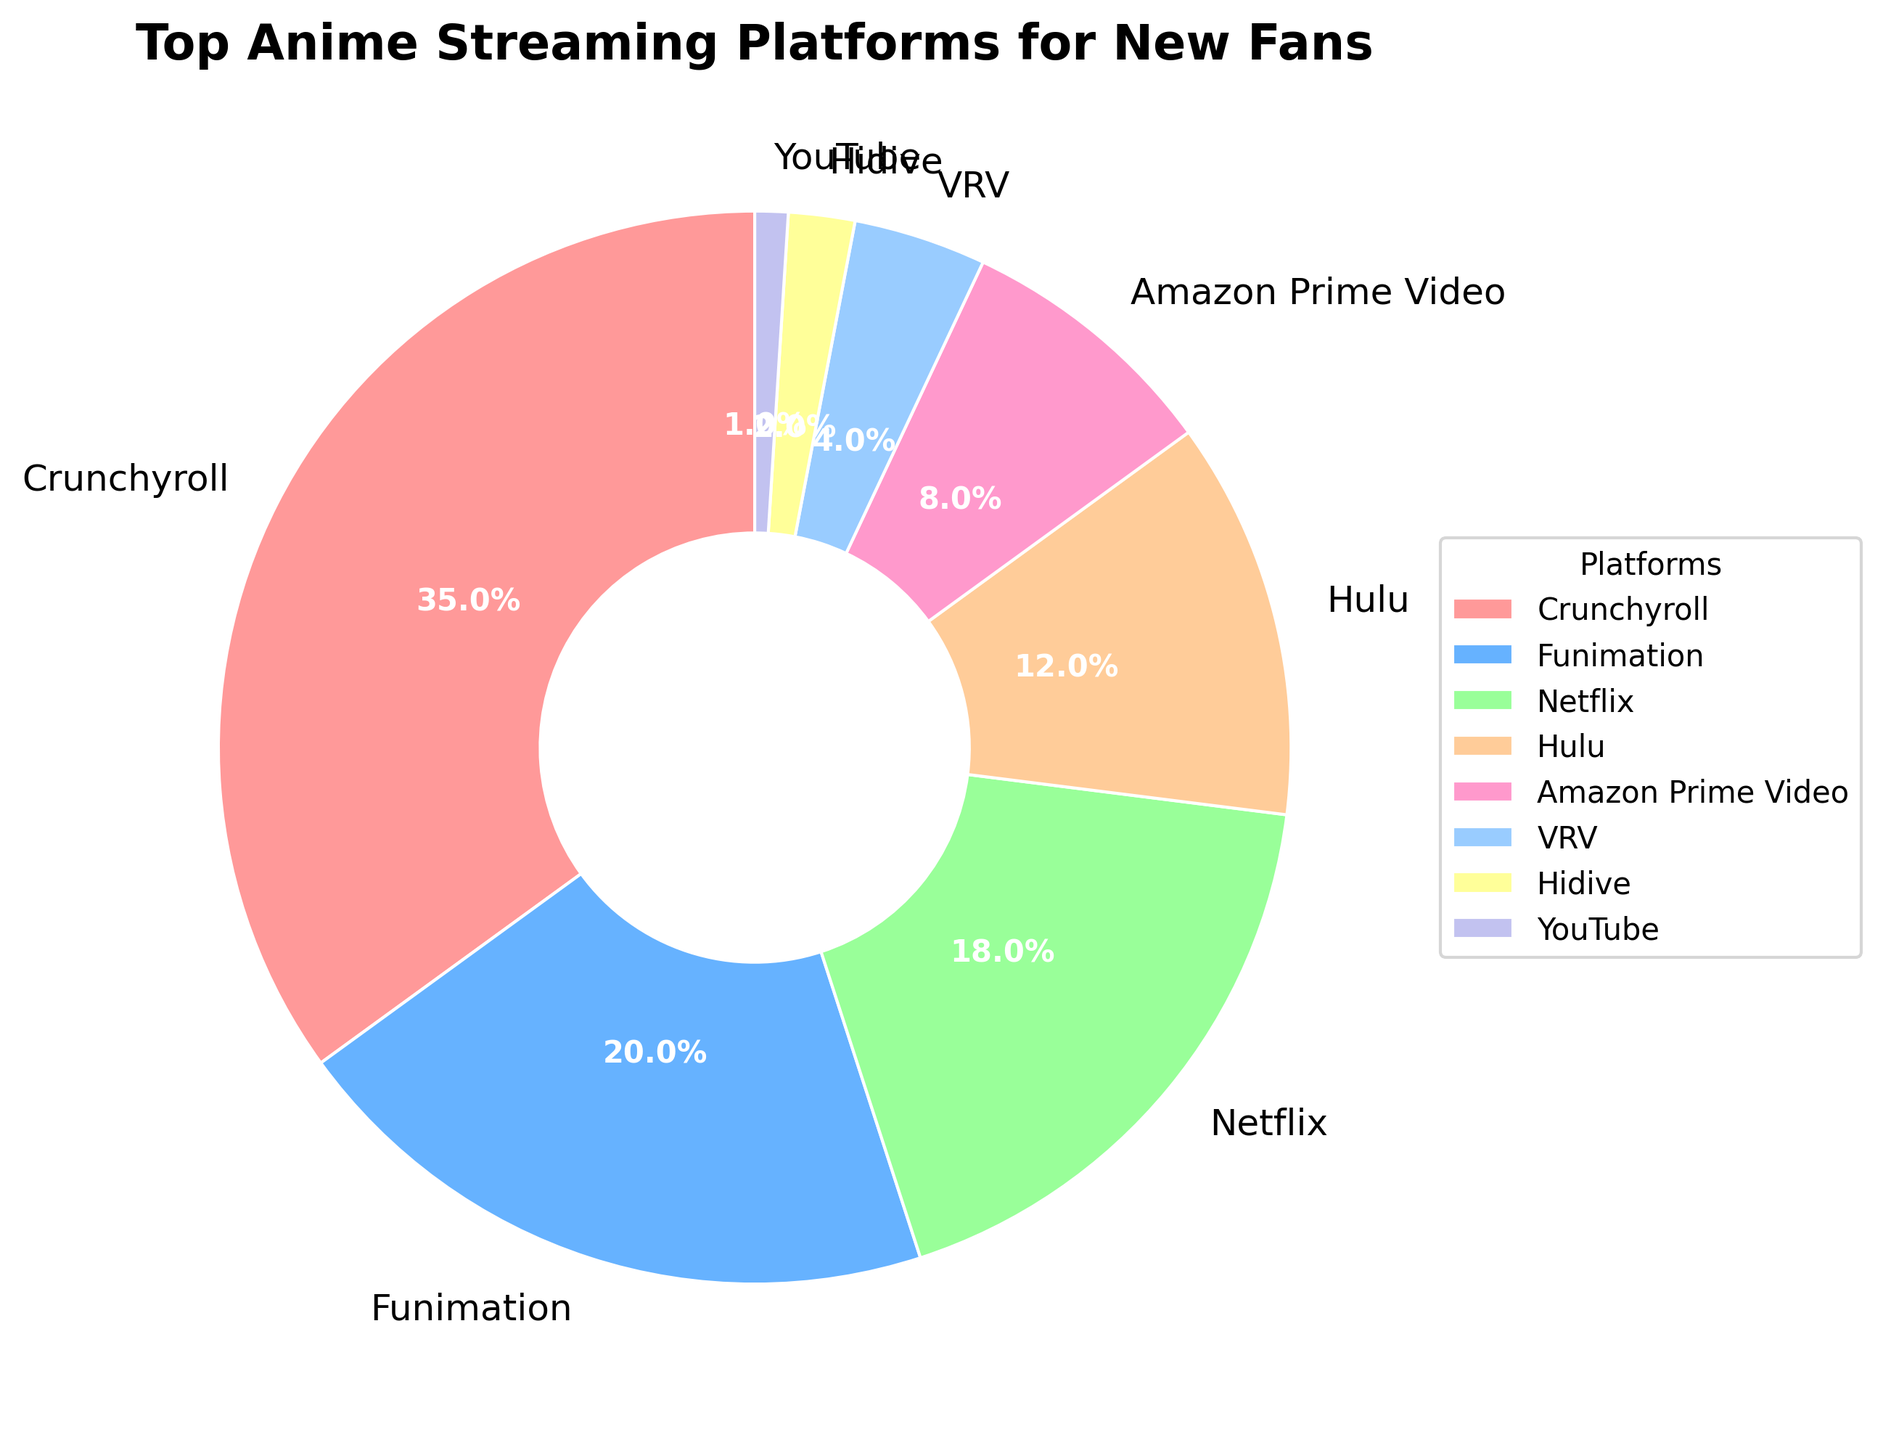What platform has the highest percentage of new anime fans? To find the platform with the highest percentage, look for the segment with the largest value in the pie chart. Crunchyroll has the largest segment.
Answer: Crunchyroll What is the combined percentage of new anime fans using Funimation and Netflix? Find the percentages for Funimation and Netflix from the chart (20% and 18%, respectively), and then add them together: 20% + 18% = 38%.
Answer: 38% Which platform has a smaller percentage of new anime fans: Hulu or Amazon Prime Video? Compare the percentages of Hulu and Amazon Prime Video. Hulu has 12%, and Amazon Prime Video has 8%, so Amazon Prime Video has the smaller percentage.
Answer: Amazon Prime Video How much larger is Crunchyroll's percentage compared to VRV's percentage? Find the percentages for Crunchyroll (35%) and VRV (4%). Subtract VRV's percentage from Crunchyroll's: 35% - 4% = 31%.
Answer: 31% Combine the percentages of platforms with less than 10% of new anime fans. Which platforms contribute to this total and what is the combined percentage? Identify platforms with less than 10%: Amazon Prime Video (8%), VRV (4%), Hidive (2%), and YouTube (1%). Add their percentages: 8% + 4% + 2% + 1% = 15%.
Answer: Amazon Prime Video, VRV, Hidive, YouTube; 15% What color is associated with Funimation in the pie chart? Look at the segment and its label for Funimation. Funimation is associated with the blue color.
Answer: Blue Rank the platforms from highest to lowest percentage. List the platforms by their percentages in descending order: Crunchyroll, Funimation, Netflix, Hulu, Amazon Prime Video, VRV, Hidive, YouTube.
Answer: Crunchyroll, Funimation, Netflix, Hulu, Amazon Prime Video, VRV, Hidive, YouTube Calculate the average percentage of new anime fans for Hulu and VRV. Find the percentages for Hulu (12%) and VRV (4%). Add them together and divide by 2: (12% + 4%) / 2 = 8%.
Answer: 8% Which platform has the least percentage of new anime fans, and what is the percentage? Find the smallest segment in the pie chart. YouTube has the smallest percentage, which is 1%.
Answer: YouTube, 1% If Crunchyroll's share is increased by 5 percentage points, what will be its new percentage? Add 5% to Crunchyroll's current percentage: 35% + 5% = 40%.
Answer: 40% 